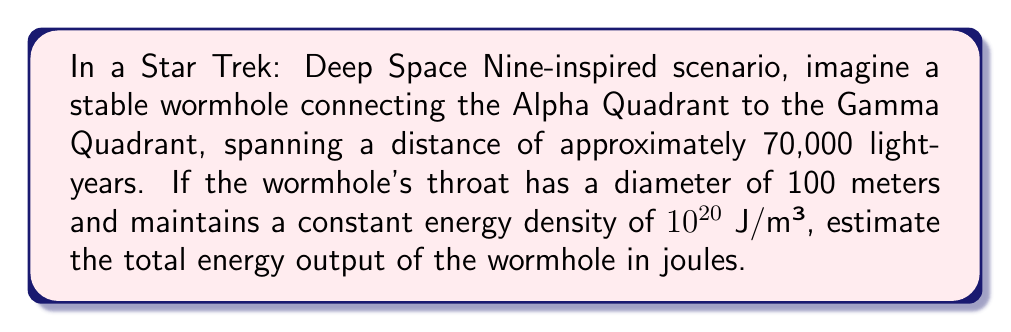Solve this math problem. Let's approach this step-by-step:

1) First, we need to calculate the volume of the wormhole. We'll assume it's roughly cylindrical for simplicity.

2) The length of the wormhole is 70,000 light-years. Let's convert this to meters:
   $$ L = 70,000 \times 9.461 \times 10^{15} \text{ m} = 6.6227 \times 10^{20} \text{ m} $$

3) The diameter is 100 meters, so the radius is 50 meters. The volume of a cylinder is $\pi r^2 L$:
   $$ V = \pi (50 \text{ m})^2 \times 6.6227 \times 10^{20} \text{ m} = 5.2002 \times 10^{24} \text{ m}^3 $$

4) The energy density is given as $10^{20}$ J/m³. To find the total energy, we multiply this by the volume:
   $$ E = 10^{20} \text{ J/m}^3 \times 5.2002 \times 10^{24} \text{ m}^3 = 5.2002 \times 10^{44} \text{ J} $$

5) This is our estimate for the total energy output of the wormhole.
Answer: $5.2 \times 10^{44}$ J 